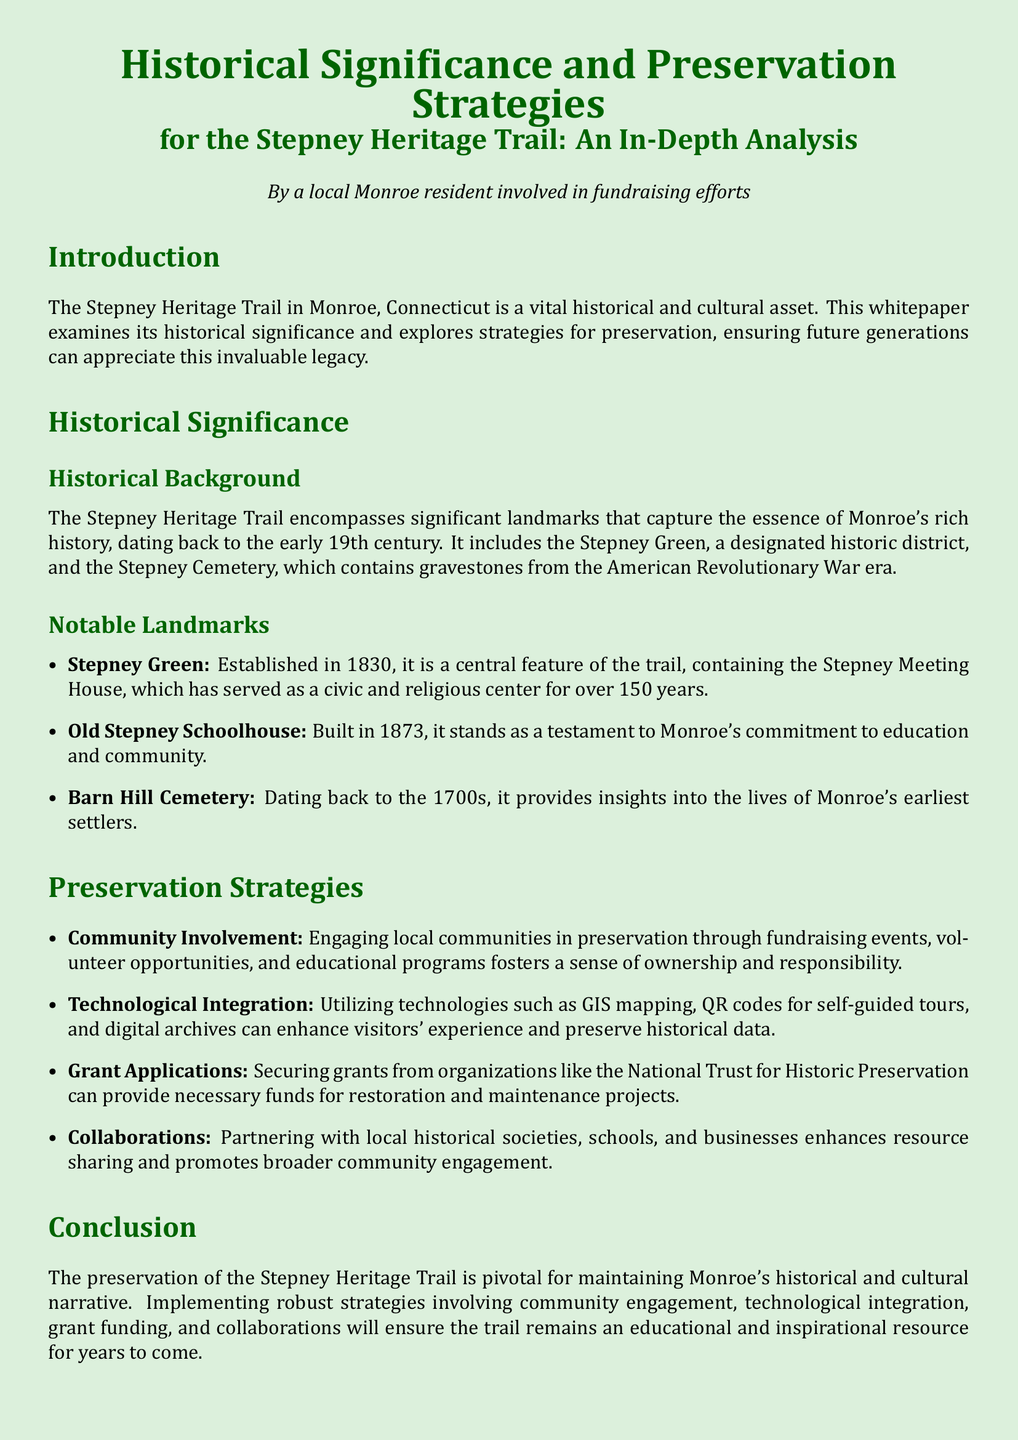What is a vital historical and cultural asset in Monroe? The document describes the Stepney Heritage Trail as a vital historical and cultural asset.
Answer: Stepney Heritage Trail When was Stepney Green established? The establishment date of Stepney Green is mentioned in the historical background section.
Answer: 1830 What significant war era is represented in the Stepney Cemetery? The document states that the Stepney Cemetery contains gravestones from a specific war era.
Answer: American Revolutionary War What year was the Old Stepney Schoolhouse built? The building year of the Old Stepney Schoolhouse is provided in the notable landmarks section.
Answer: 1873 What is a preservation strategy that involves securing funds? The document lists a strategy specifically focused on obtaining financial support for preservation efforts.
Answer: Grant Applications Which landmark served as a civic and religious center for over 150 years? The document refers to a landmark that has had a significant community role for a long time.
Answer: Stepney Meeting House How can technology enhance the visitor experience according to the document? The document mentions the use of technologies for providing visitors with information during their experience on the trail.
Answer: GIS mapping What is essential for maintaining Monroe's historical narrative? The conclusion emphasizes a crucial aspect for preserving local history.
Answer: Preservation of the Stepney Heritage Trail 